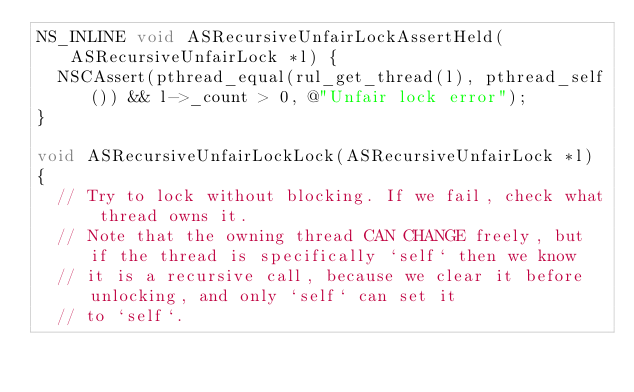<code> <loc_0><loc_0><loc_500><loc_500><_ObjectiveC_>NS_INLINE void ASRecursiveUnfairLockAssertHeld(ASRecursiveUnfairLock *l) {
  NSCAssert(pthread_equal(rul_get_thread(l), pthread_self()) && l->_count > 0, @"Unfair lock error");
}

void ASRecursiveUnfairLockLock(ASRecursiveUnfairLock *l)
{
  // Try to lock without blocking. If we fail, check what thread owns it.
  // Note that the owning thread CAN CHANGE freely, but if the thread is specifically `self` then we know
  // it is a recursive call, because we clear it before unlocking, and only `self` can set it
  // to `self`.
</code> 